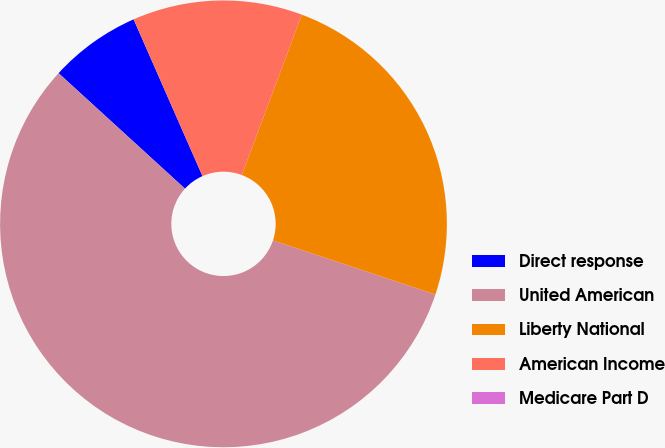Convert chart to OTSL. <chart><loc_0><loc_0><loc_500><loc_500><pie_chart><fcel>Direct response<fcel>United American<fcel>Liberty National<fcel>American Income<fcel>Medicare Part D<nl><fcel>6.63%<fcel>56.66%<fcel>24.42%<fcel>12.29%<fcel>0.0%<nl></chart> 